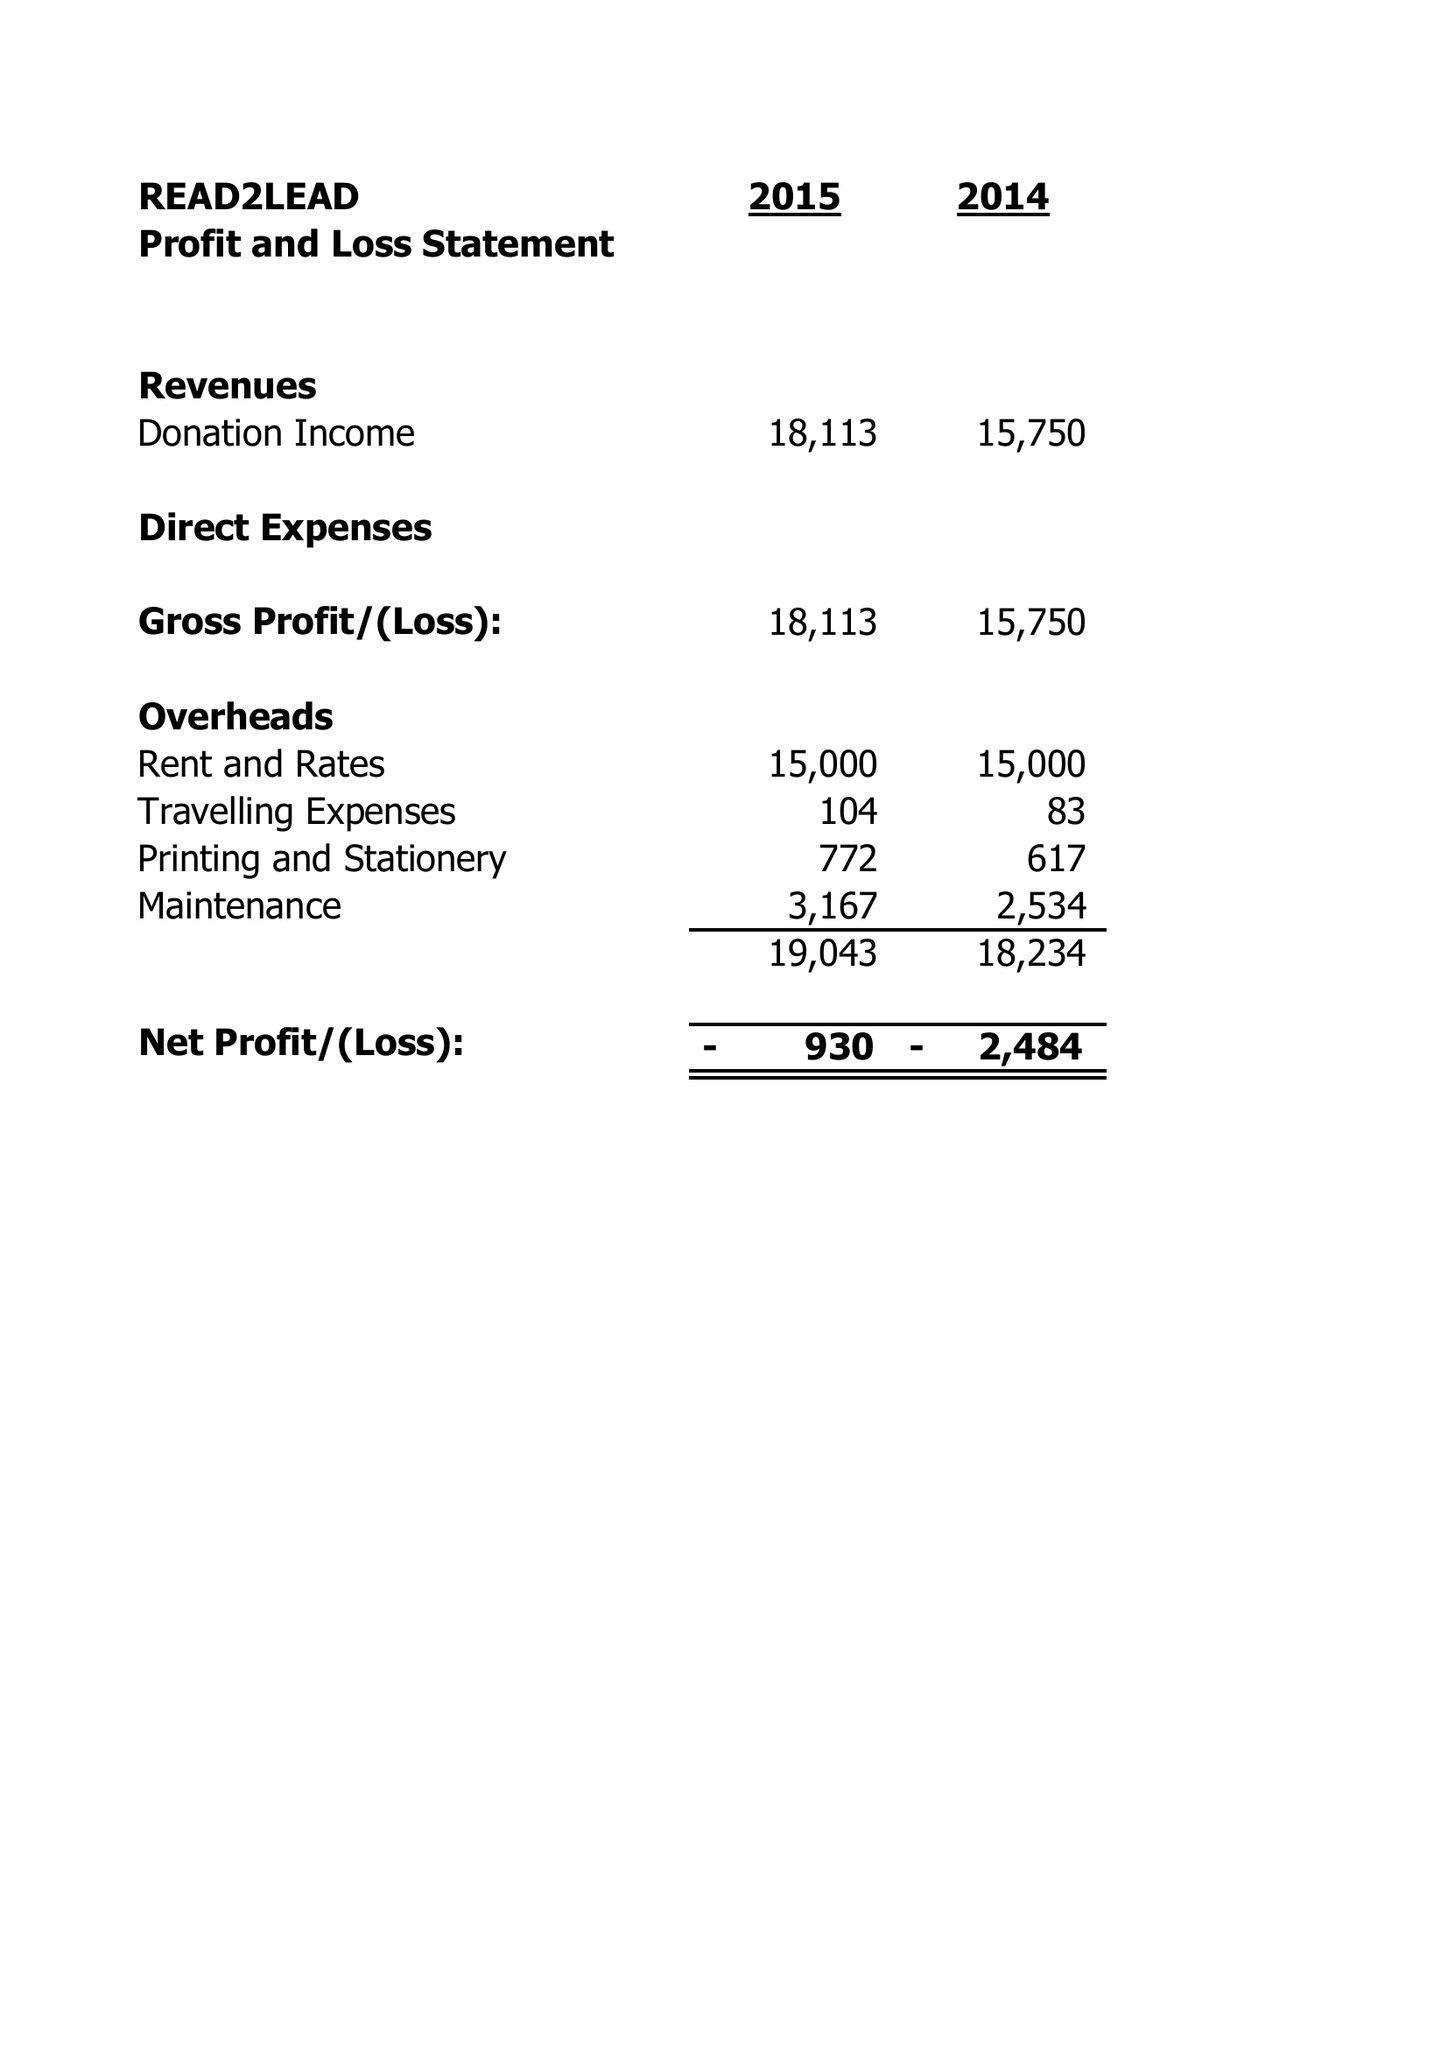What is the value for the charity_name?
Answer the question using a single word or phrase. Read2lead 